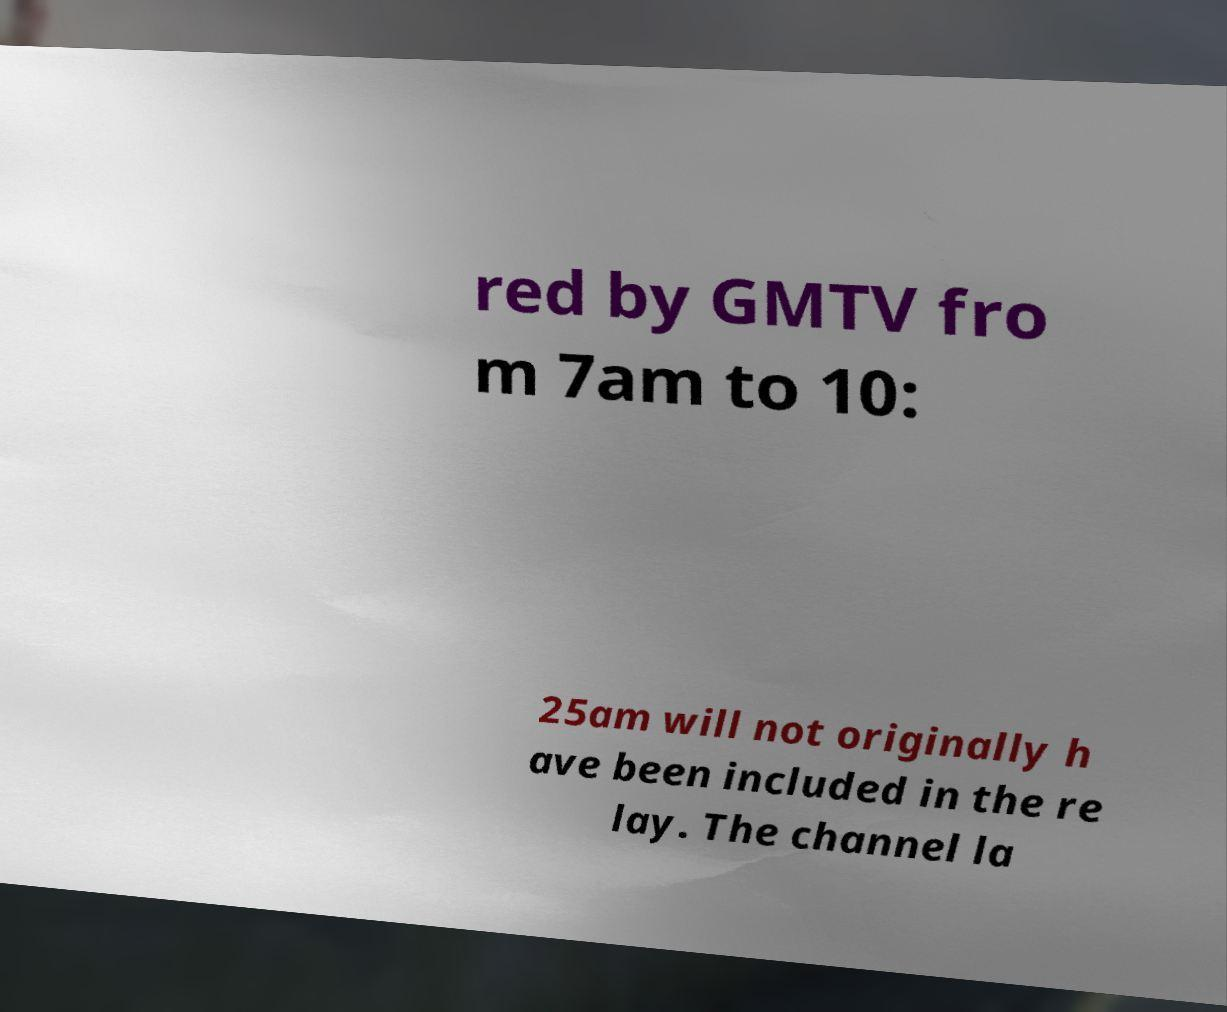For documentation purposes, I need the text within this image transcribed. Could you provide that? red by GMTV fro m 7am to 10: 25am will not originally h ave been included in the re lay. The channel la 